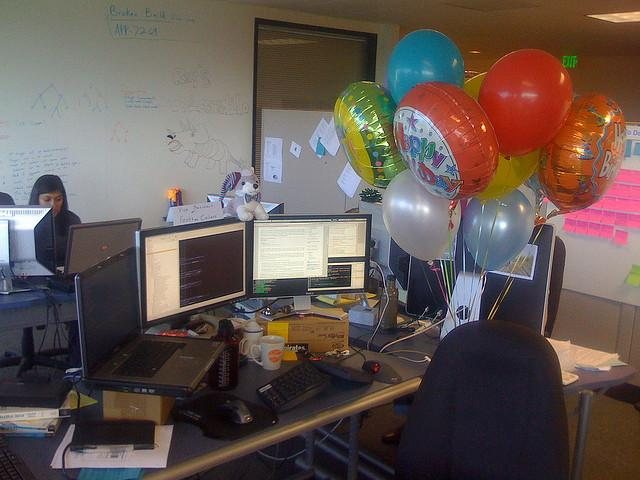What sort of wax item might be on a dessert enjoyed by the person sitting by the balloons today? Please explain your reasoning. birthday candle. A birthday cake usually has candles on it. 